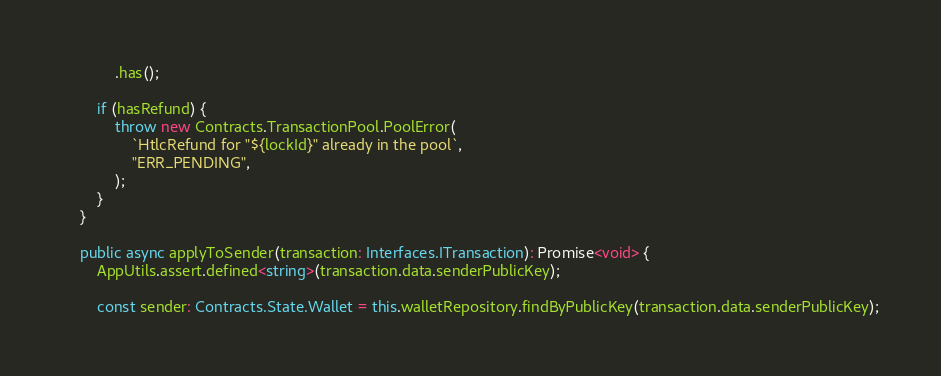<code> <loc_0><loc_0><loc_500><loc_500><_TypeScript_>            .has();

        if (hasRefund) {
            throw new Contracts.TransactionPool.PoolError(
                `HtlcRefund for "${lockId}" already in the pool`,
                "ERR_PENDING",
            );
        }
    }

    public async applyToSender(transaction: Interfaces.ITransaction): Promise<void> {
        AppUtils.assert.defined<string>(transaction.data.senderPublicKey);

        const sender: Contracts.State.Wallet = this.walletRepository.findByPublicKey(transaction.data.senderPublicKey);
</code> 